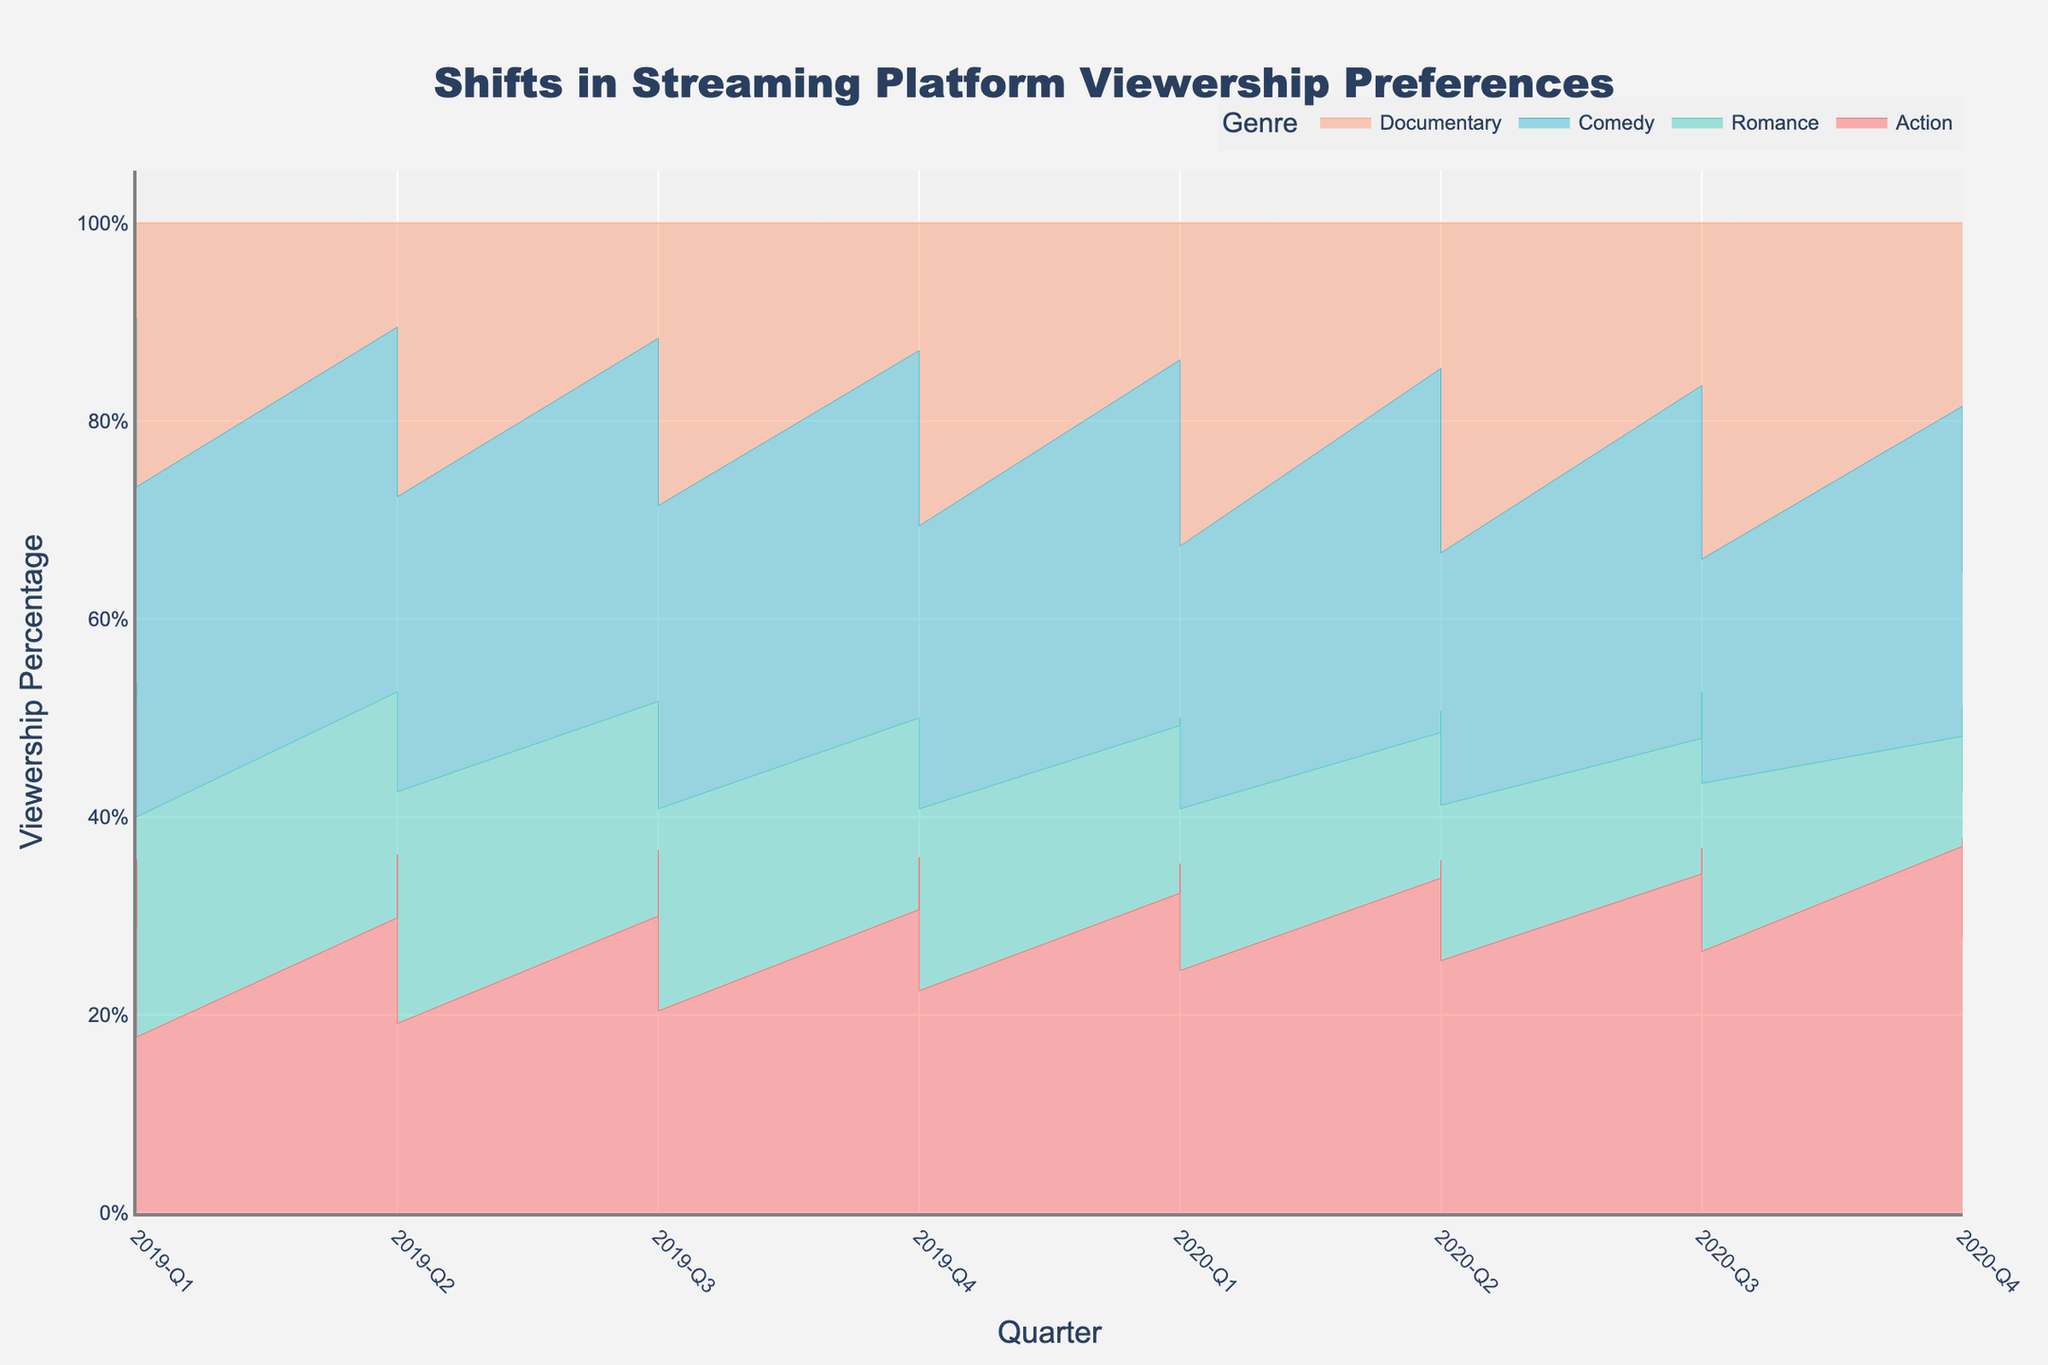what is the title of the chart? The title can usually be found at the top of a chart and it provides a clear summary of what the chart is about.
Answer: Shifts in Streaming Platform Viewership Preferences How many genres are represented in the chart? By identifying the different segments in the step area chart, each representing a different genre, you can count how many genres are included.
Answer: Four Which genre has the highest viewership in 2020-Q4 for the 18-24 age group? To answer this, locate the section of the step area chart corresponding to the 18-24 age group and the time period of 2020-Q4, then identify the highest segment.
Answer: Action Between which quarters did the 25-34 age group see the greatest increase in Documentary viewership? First, observe the 25-34 age group's Documentary genre line in the chart. Identify the largest change in height between quarters, reflecting the greatest increase.
Answer: 2020-Q2 to 2020-Q3 Which age group had the most significant decline in Romance viewership from 2019-Q1 to 2020-Q4? Look for each age group's Romance genre trend line and compare the decline from 2019-Q1 to 2020-Q4. Identify the age group with the most significant drop.
Answer: 18-24 How did the Action genre viewership change for the 45-54 age group over the time period? Trace the step area for the 45-54 age group focusing on the Action genre from 2019-Q1 to 2020-Q4, noting any increments or decrements.
Answer: It steadily increased Which genre displayed the most consistent viewership percentage across all quarters for the 55+ age group? Examine each genre line within the 55+ age group section and determine which line shows the least fluctuation across the entire time period.
Answer: Comedy In which quarter did the 35-44 age group see the peak viewership for Comedy? Find the line representing the Comedy genre within the 35-44 age group and identify the highest point along the time axis.
Answer: 2020-Q1 Compare the Documentary viewership between the 18-24 and 55+ age groups in 2020-Q4. Which age group had higher viewership? Check the Documentary genre's endpoint at 2020-Q4 for both age groups and compare the heights to determine which one is higher.
Answer: 18-24 What is the pattern of Romance viewership for the 55+ age group from 2019-Q1 to 2020-Q4? Follow the Romance genre's line for the 55+ age group across all quarters, noting the increase and decrease in viewership.
Answer: It fluctuates but generally decreases 